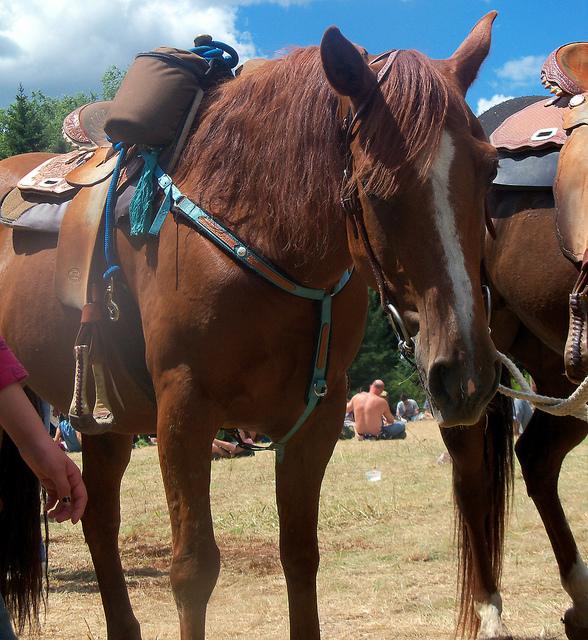Which horse has a harder job?
Write a very short answer. Left. What body part is sticking into the photo on the far left side?
Write a very short answer. Arm. Where is the shirtless man sitting?
Keep it brief. On ground. How many horses are shown?
Quick response, please. 2. 